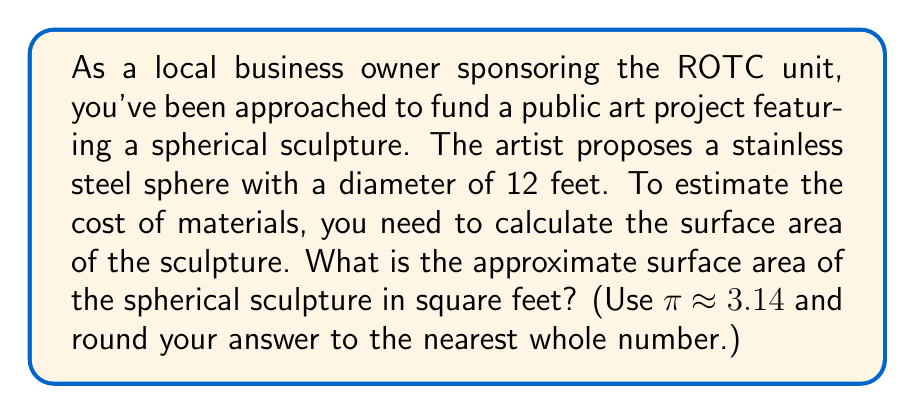Help me with this question. To solve this problem, we'll use the formula for the surface area of a sphere and follow these steps:

1. Formula for the surface area of a sphere:
   $$A = 4πr^2$$
   where A is the surface area and r is the radius of the sphere.

2. Given information:
   - Diameter of the sphere = 12 feet
   - Radius is half the diameter, so r = 6 feet

3. Substitute the values into the formula:
   $$A = 4π(6^2)$$

4. Simplify:
   $$A = 4π(36)$$
   $$A = 144π$$

5. Use π ≈ 3.14:
   $$A ≈ 144 * 3.14$$
   $$A ≈ 452.16 \text{ square feet}$$

6. Round to the nearest whole number:
   $$A ≈ 452 \text{ square feet}$$

This calculation provides an estimate of the surface area, which can help determine the amount of stainless steel needed for the sculpture and assist in estimating material costs for the public art project.
Answer: The approximate surface area of the spherical sculpture is 452 square feet. 